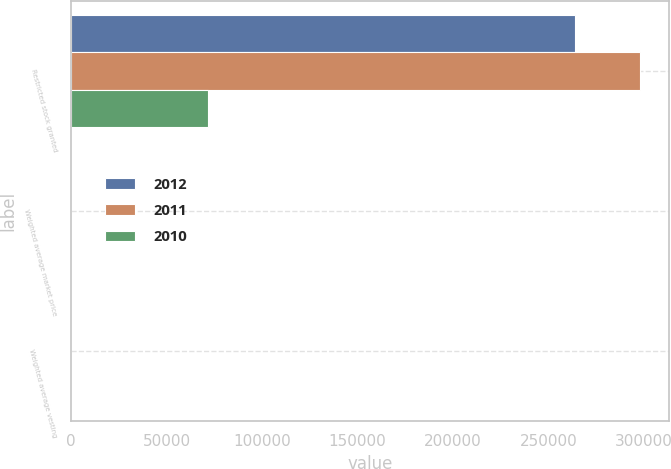<chart> <loc_0><loc_0><loc_500><loc_500><stacked_bar_chart><ecel><fcel>Restricted stock granted<fcel>Weighted average market price<fcel>Weighted average vesting<nl><fcel>2012<fcel>263771<fcel>44.82<fcel>3.09<nl><fcel>2011<fcel>297859<fcel>38.44<fcel>2.27<nl><fcel>2010<fcel>71752<fcel>38.43<fcel>4.74<nl></chart> 